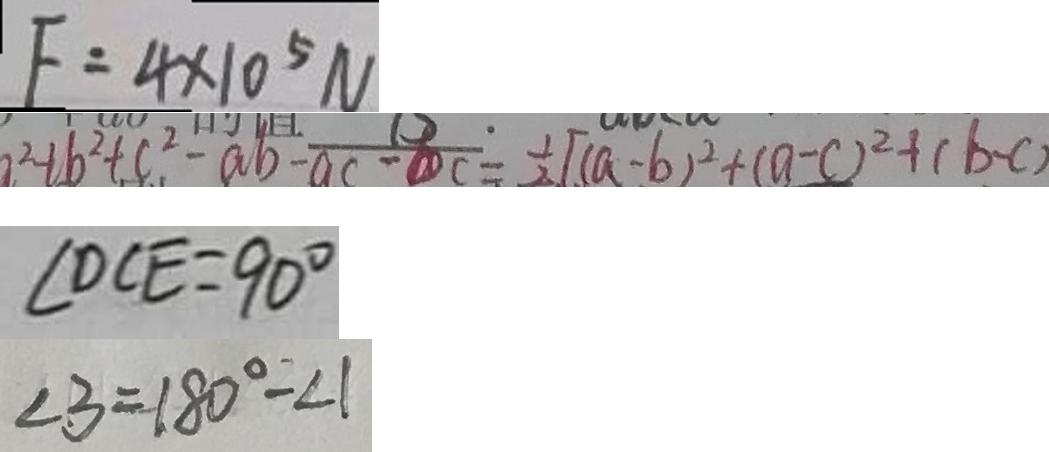Convert formula to latex. <formula><loc_0><loc_0><loc_500><loc_500>F = 4 \times 1 0 ^ { 5 } N 
 a ^ { 2 } + b ^ { 2 } + c ^ { 2 } - a b - a c - c = \frac { 1 } { 2 } [ ( a - b ) ^ { 2 } + ( a - c ) ^ { 2 } + ( b - c ) 
 \angle D C E = 9 0 ^ { \circ } 
 \angle 3 = 1 8 0 ^ { \circ } - \angle 1</formula> 